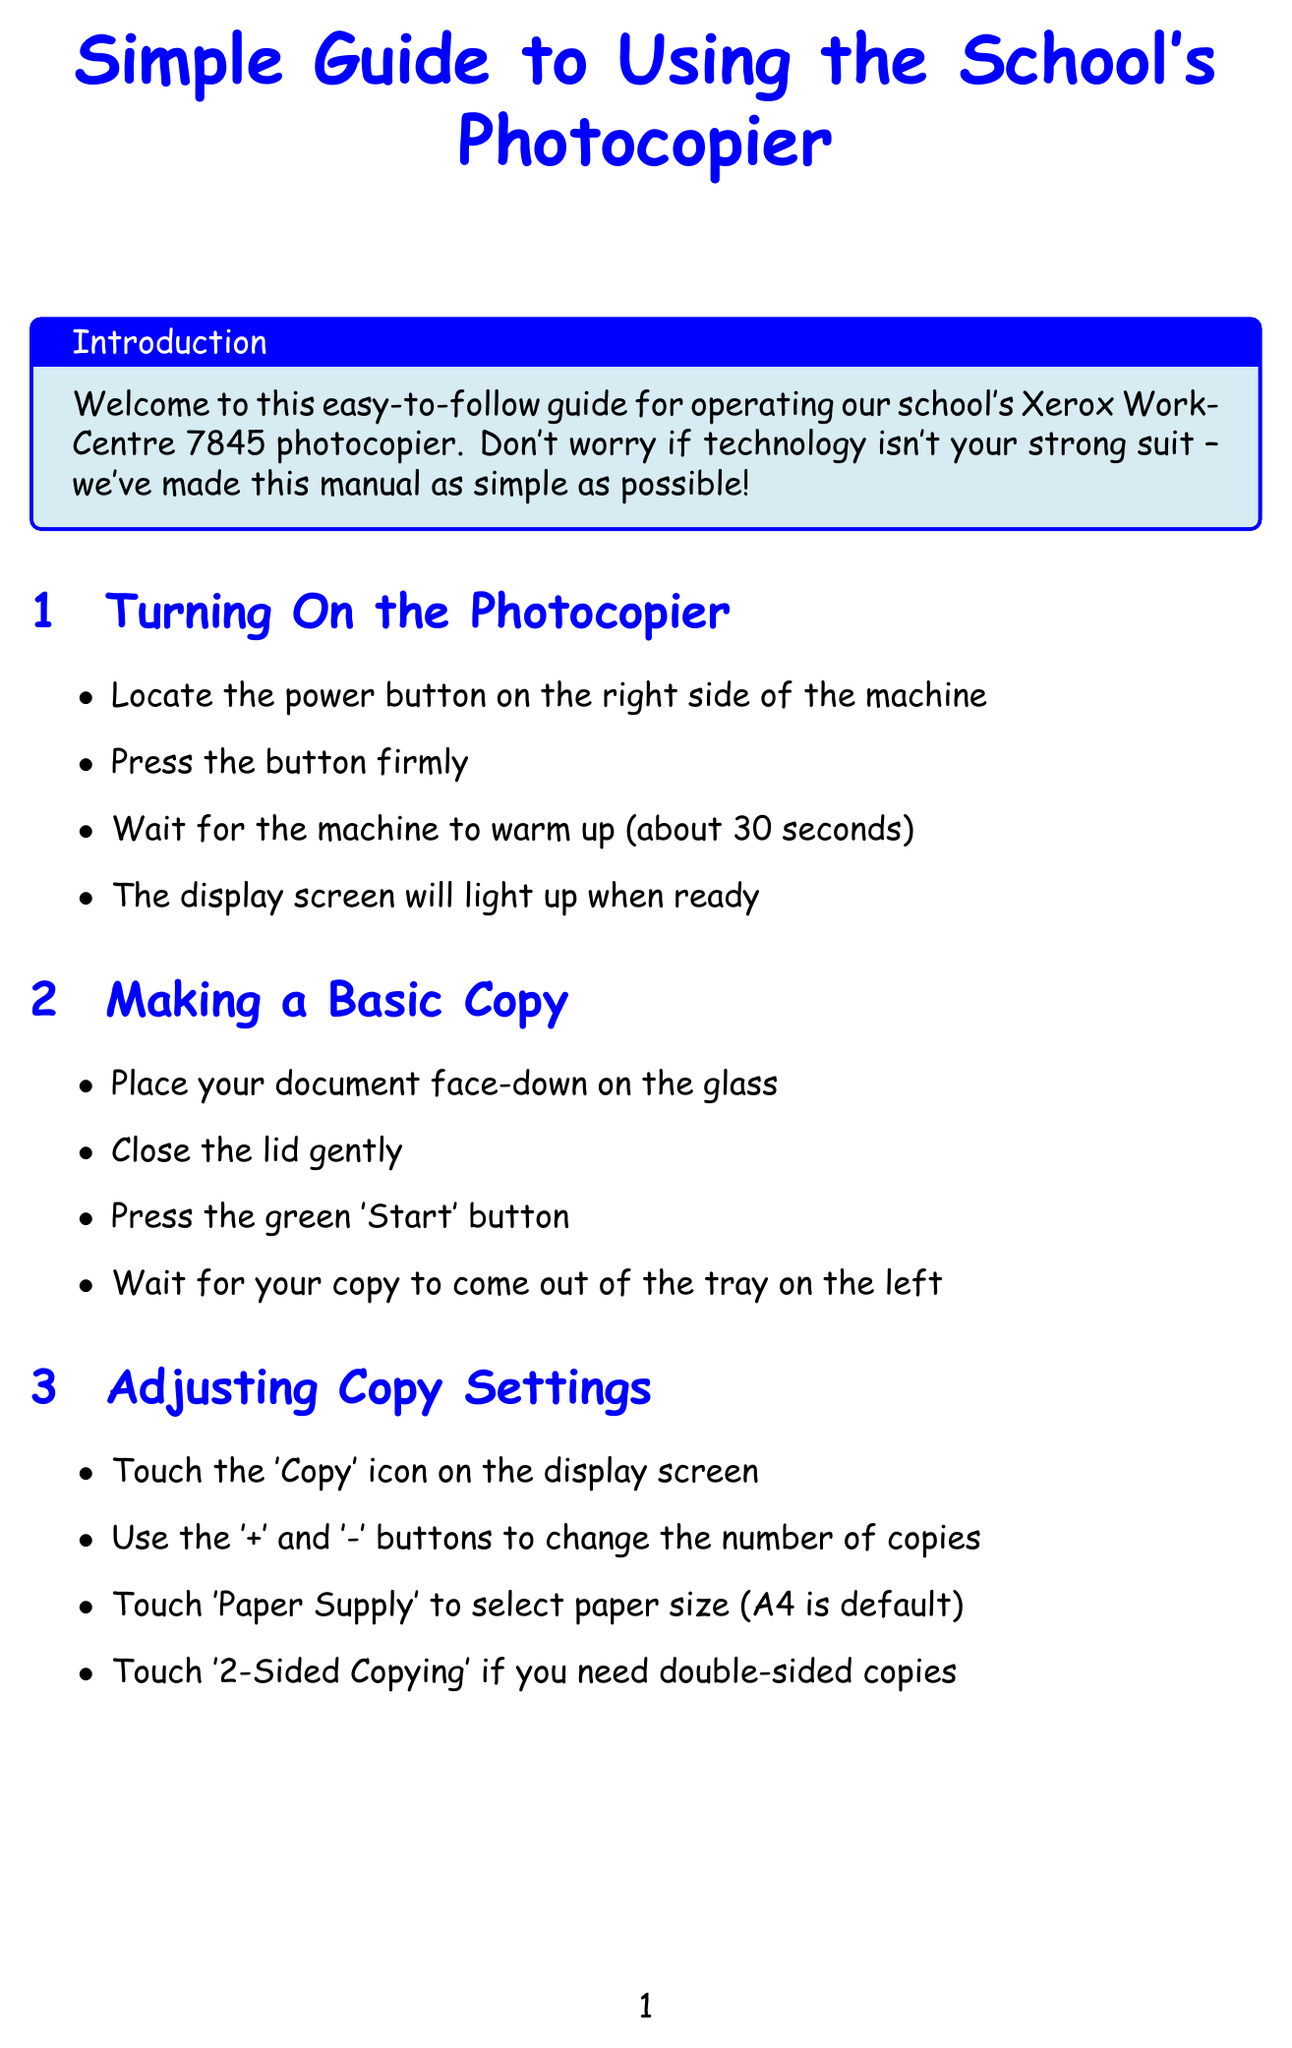What is the model of the photocopier? The model mentioned in the document is the Xerox WorkCentre 7845.
Answer: Xerox WorkCentre 7845 How long does the photocopier take to warm up? The document states that the machine will warm up for about 30 seconds.
Answer: 30 seconds What button should you press to start copying? According to the manual, the green 'Start' button should be pressed to initiate copying.
Answer: green 'Start' button What should you do if there is a paper jam? The solution for a paper jam includes gently removing any visible jammed paper.
Answer: remove jammed paper What size is the default paper size in the photocopier? The default paper size mentioned in the document is A4.
Answer: A4 What advice is given to protect privacy after using the copier? The document advises to log out or press 'Clear All' when finished using the photocopier.
Answer: log out or press 'Clear All' What should you check if the copier won't turn on? The manual suggests checking if the power cord is properly plugged in.
Answer: power cord How can you adjust the number of copies? You can change the number of copies using the '+' and '-' buttons on the display.
Answer: '+' and '-' buttons What should you do when you see a low toner warning? The solution includes gently shaking the toner cartridge side to side.
Answer: shake the cartridge 